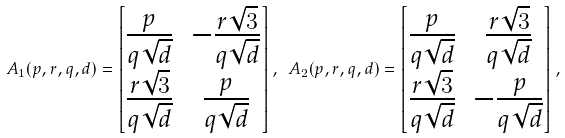Convert formula to latex. <formula><loc_0><loc_0><loc_500><loc_500>A _ { 1 } ( p , r , q , d ) = \begin{bmatrix} \frac { p } { q \sqrt { d } } & - \frac { r \sqrt { 3 } } { q \sqrt { d } } \\ \frac { r \sqrt { 3 } } { q \sqrt { d } } & \frac { p } { q \sqrt { d } } \end{bmatrix} , \ A _ { 2 } ( p , r , q , d ) = \begin{bmatrix} \frac { p } { q \sqrt { d } } & \frac { r \sqrt { 3 } } { q \sqrt { d } } \\ \frac { r \sqrt { 3 } } { q \sqrt { d } } & - \frac { p } { q \sqrt { d } } \end{bmatrix} ,</formula> 